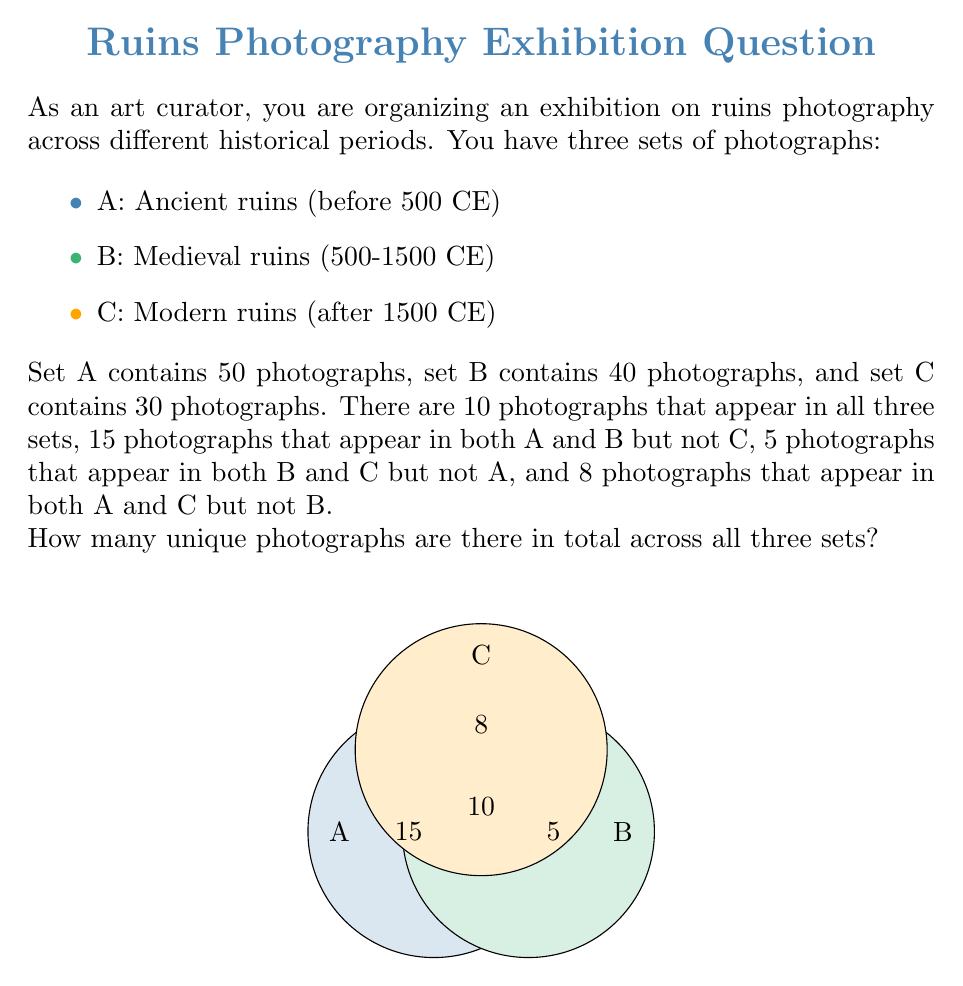Can you answer this question? Let's approach this step-by-step using set theory:

1) First, let's define our universal set $U$ as the set of all unique photographs.

2) We can use the inclusion-exclusion principle to find $|U|$:

   $|U| = |A \cup B \cup C| = |A| + |B| + |C| - |A \cap B| - |B \cap C| - |A \cap C| + |A \cap B \cap C|$

3) We know:
   $|A| = 50$
   $|B| = 40$
   $|C| = 30$
   $|A \cap B \cap C| = 10$

4) We need to calculate $|A \cap B|$, $|B \cap C|$, and $|A \cap C|$:

   $|A \cap B| = 15 + 10 = 25$ (photos in A and B but not C, plus photos in all three)
   $|B \cap C| = 5 + 10 = 15$
   $|A \cap C| = 8 + 10 = 18$

5) Now we can substitute these values into our equation:

   $|U| = 50 + 40 + 30 - 25 - 15 - 18 + 10$

6) Simplifying:
   $|U| = 120 - 58 + 10 = 72$

Therefore, there are 72 unique photographs across all three sets.
Answer: 72 